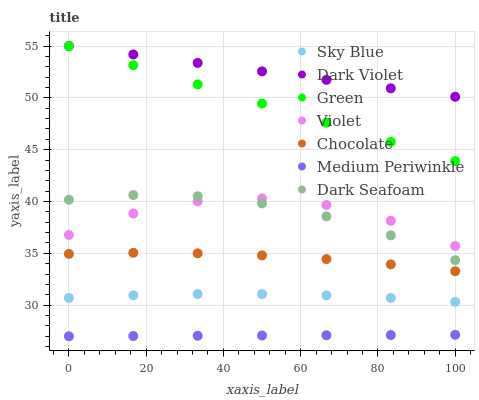Does Medium Periwinkle have the minimum area under the curve?
Answer yes or no. Yes. Does Dark Violet have the maximum area under the curve?
Answer yes or no. Yes. Does Chocolate have the minimum area under the curve?
Answer yes or no. No. Does Chocolate have the maximum area under the curve?
Answer yes or no. No. Is Medium Periwinkle the smoothest?
Answer yes or no. Yes. Is Violet the roughest?
Answer yes or no. Yes. Is Dark Violet the smoothest?
Answer yes or no. No. Is Dark Violet the roughest?
Answer yes or no. No. Does Medium Periwinkle have the lowest value?
Answer yes or no. Yes. Does Chocolate have the lowest value?
Answer yes or no. No. Does Green have the highest value?
Answer yes or no. Yes. Does Chocolate have the highest value?
Answer yes or no. No. Is Sky Blue less than Dark Violet?
Answer yes or no. Yes. Is Dark Violet greater than Sky Blue?
Answer yes or no. Yes. Does Dark Violet intersect Green?
Answer yes or no. Yes. Is Dark Violet less than Green?
Answer yes or no. No. Is Dark Violet greater than Green?
Answer yes or no. No. Does Sky Blue intersect Dark Violet?
Answer yes or no. No. 